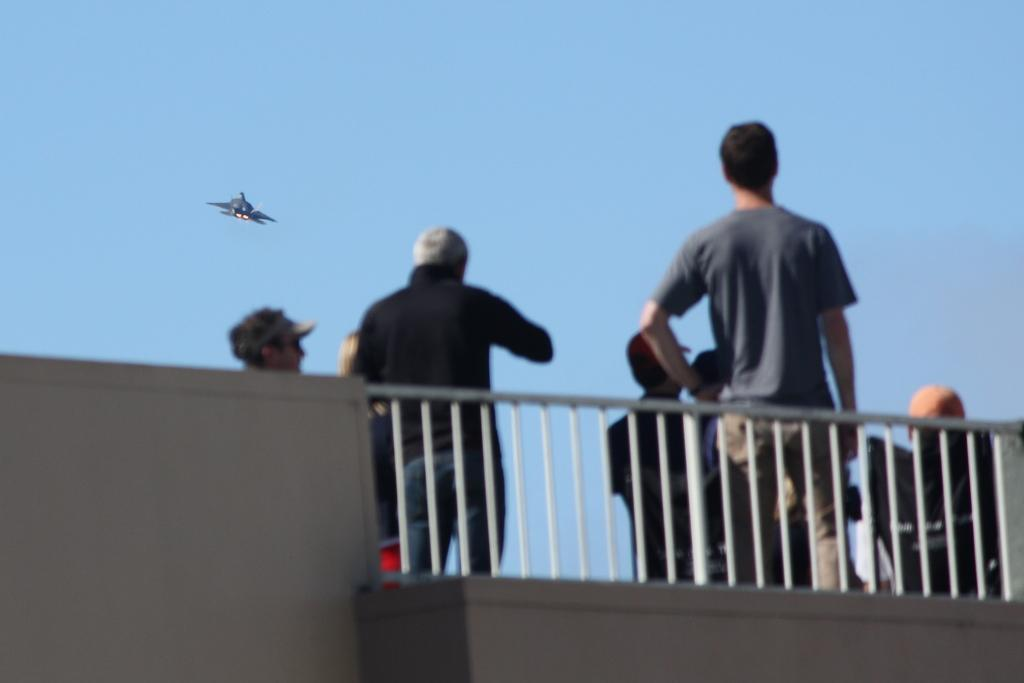What is the position of the man in the image? The man is standing on the right side of the image. What is the man wearing in the image? The man is wearing a t-shirt in the image. What is the position of the person in the image? The person is standing on the left side of the image. What is the person wearing in the image? The person is wearing a black color t-shirt in the image. What can be seen in the sky at the top of the image? There is an airplane flying in the sky at the top of the image. What type of writing can be seen on the furniture in the image? There is no furniture present in the image, so no writing can be seen on it. 